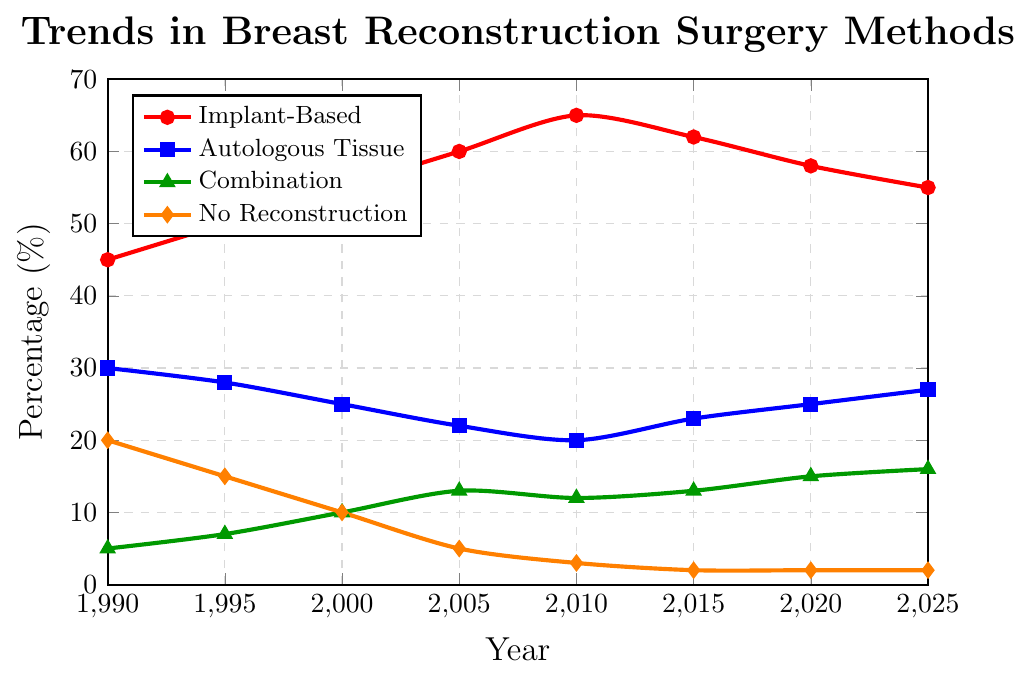What's the trend for the percentage of Implant-Based reconstruction from 1990 to 2025? The percentage of Implant-Based reconstruction increased from 45% in 1990 to a peak of 65% in 2010, then slightly decreased to 55% by 2025.
Answer: Increase, then decrease How does the percentage of Autologous Tissue reconstruction in 2020 compare to that in 1990? The percentage of Autologous Tissue reconstruction was 30% in 1990 and increased to 25% in 2020.
Answer: Decrease Which reconstruction method had the highest percentage increase from 1990 to 2025? Combination method increased from 5% in 1990 to 16% in 2025, which is an 11% increase. Other methods had smaller changes.
Answer: Combination By how much did the percentage of "No Reconstruction" decrease from 1990 to 2010? The percentage of "No Reconstruction" was 20% in 1990 and decreased to 3% in 2010. The change is 20% - 3% = 17%.
Answer: 17% What is the average percentage of Implant-Based reconstruction across all years? The percentages are 45, 50, 55, 60, 65, 62, 58, and 55. The sum is 450. There are 8 years, so the average is 450/8 = 56.25
Answer: 56.25 Which year had the lowest percentage for No Reconstruction? The percentages for No Reconstruction are 20, 15, 10, 5, 3, 2, 2, and 2 across the years. The lowest value is 2, which occurred in 2015, 2020, and 2025.
Answer: 2015, 2020, 2025 How did the percentage of Combination methods change from 1990 to 2005? The percentage of Combination methods increased from 5% in 1990 to 13% in 2005. The change is 13% - 5% = 8%.
Answer: Increase by 8% In 2025, by how much does the percentage of Autologous Tissue methods exceed the percentage of No Reconstruction? The percentage of Autologous Tissue is 27% and No Reconstruction is 2%. The difference is 27% - 2% = 25%.
Answer: 25% What is the percentage difference between Implant-Based and Combination methods in 2020? The percentage of Implant-Based is 58% and Combination is 15%, the difference is 58% - 15% = 43%.
Answer: 43% 